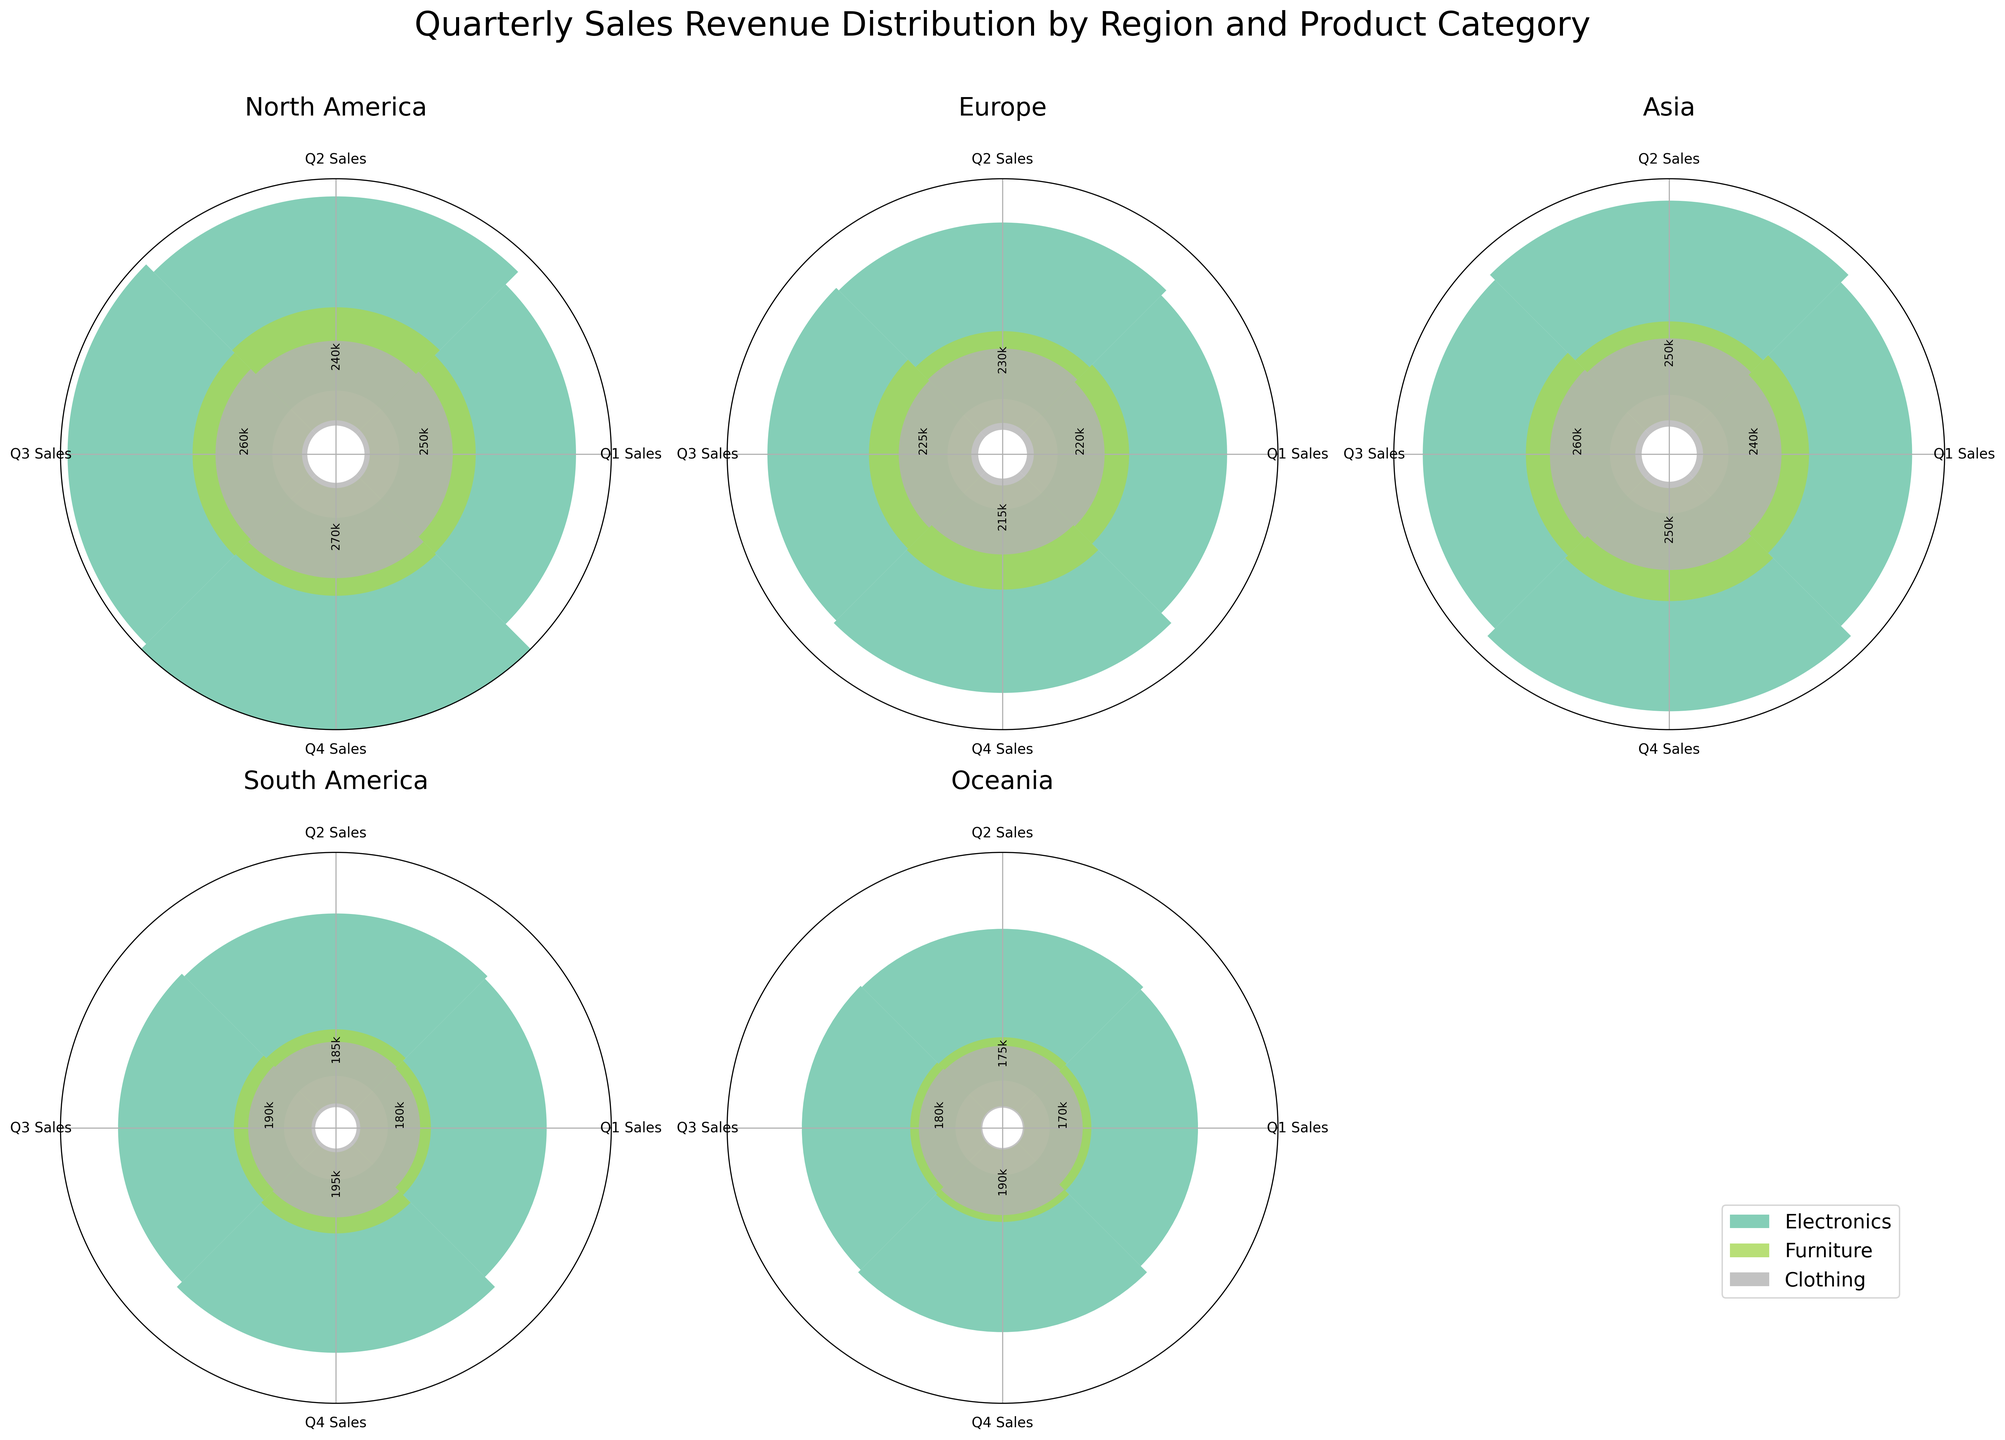What's the title of the figure? The title of the figure is placed at the top and is typically the most noticeable text in a plot. The title for this figure is 'Quarterly Sales Revenue Distribution by Region and Product Category'.
Answer: Quarterly Sales Revenue Distribution by Region and Product Category How many regions are represented in the figure? The regions are represented by the titles of each subplot. There are titles for North America, Europe, Asia, South America, and Oceania. This totals to 5 regions.
Answer: 5 Which product category in North America had the highest sales in Q3? By looking at the subplot for North America, we can see that the bar heights for Q3 can be compared. The tallest bar is for Electronics in Q3.
Answer: Electronics What is the total sales revenue for Clothes in Asia across all quarters? To find the total sales, sum the sales for Clothes in Asia across all quarters: Q1 (240000) + Q2 (250000) + Q3 (260000) + Q4 (250000). This gives a total of 1000000.
Answer: 1000000 How do Q2 sales of Electronics in Europe compare with Q2 sales of Electronics in South America? By looking at the relative bar heights for Q2 in both regions, it is evident that the Q2 sales of Electronics in Europe (500000) are higher than in South America (460000).
Answer: Europe > South America What is the average Q4 sales among all product categories in Oceania? The Q4 sales in Oceania for each category are: Electronics (445000), Furniture (205000), and Clothing (190000). Summing these gives 840000, and the average is 840000/3 = 280000.
Answer: 280000 Which region shows the least variation in Quarterly sales for Furniture? Examine the height differences in the bars for Furniture across quarters for each region. South America shows the least variation, with steady progression from 200000 in Q1 to 230000 in Q4.
Answer: South America In which region did Clothes sales decline in Q4 compared to Q3? Observing the subplots, Europe shows a decline in Q4 for Clothes from Q3's 225000 to Q4's 215000. This is the only region with a decline.
Answer: Europe 